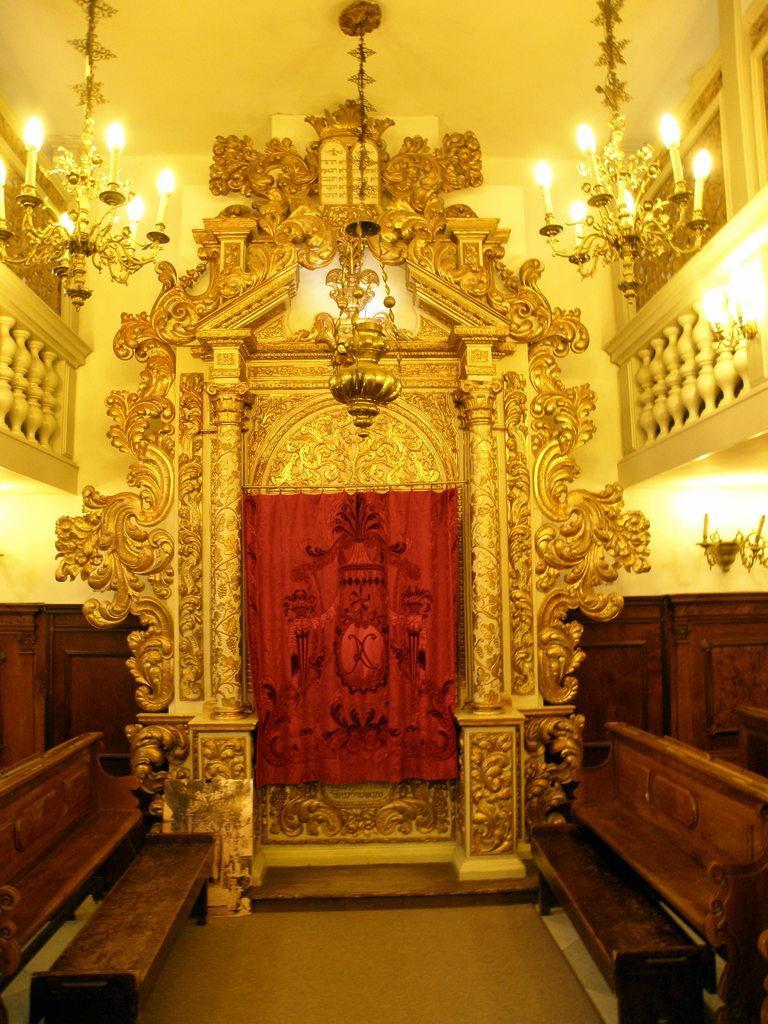In one or two sentences, can you explain what this image depicts? In this image I can see the inner part of the building and I can see two benches, two chandeliers. In the background I can see the curtain in red color and I can also see an arch and the wall is in cream color. 